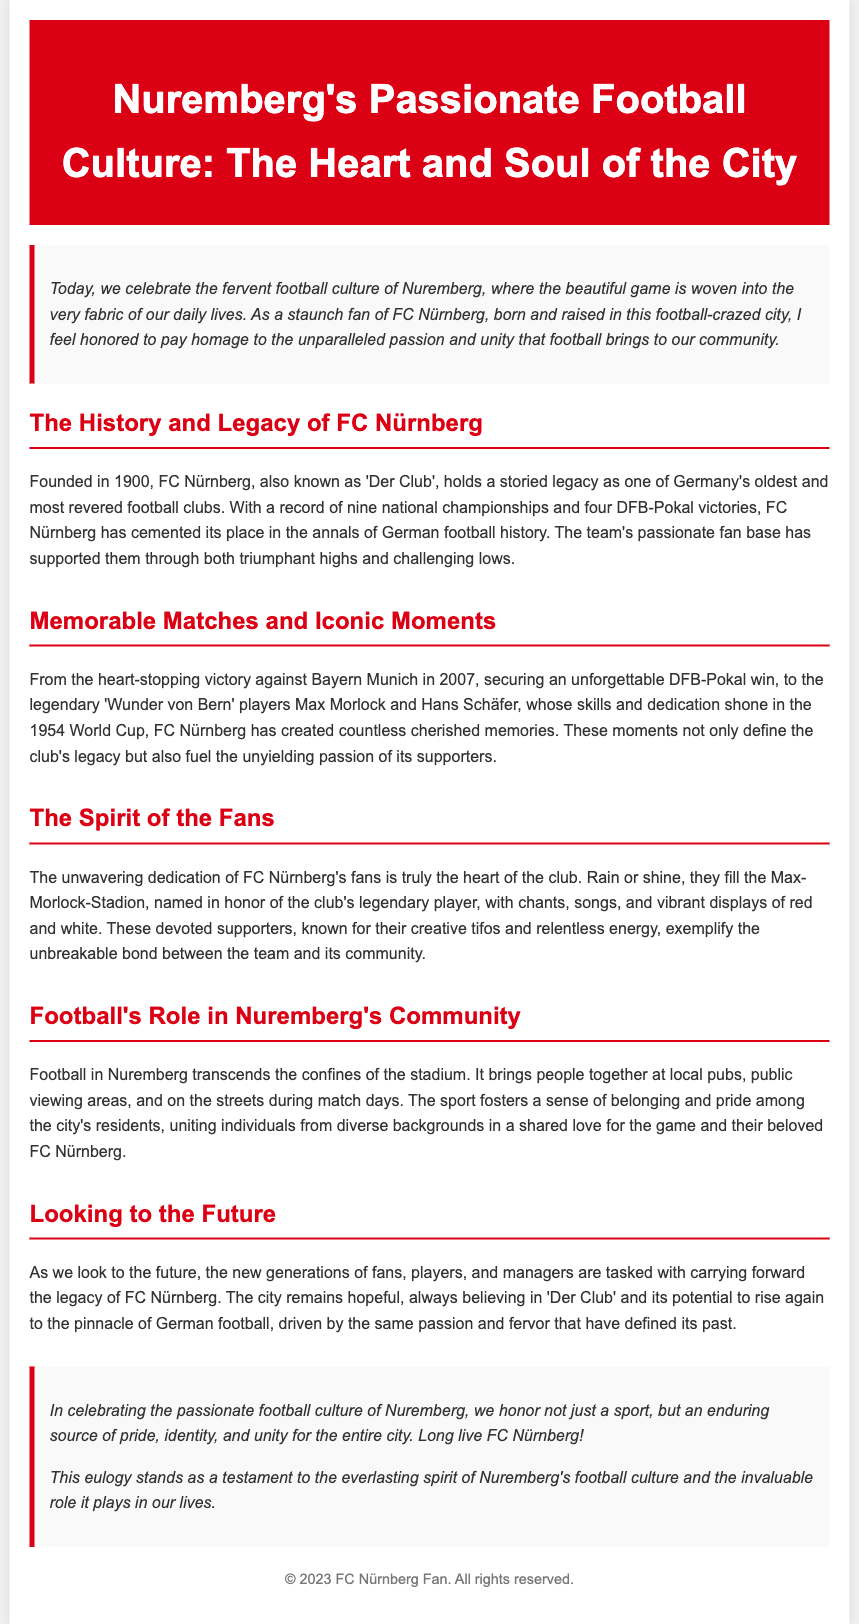What year was FC Nürnberg founded? The document states that FC Nürnberg was founded in 1900.
Answer: 1900 How many national championships has FC Nürnberg won? According to the document, FC Nürnberg has a record of nine national championships.
Answer: Nine What iconic moment is mentioned from the year 2007? The document highlights the heart-stopping victory against Bayern Munich in 2007.
Answer: Victory against Bayern Munich Who are the legendary players mentioned in the 'Wunder von Bern'? The document mentions Max Morlock and Hans Schäfer as the legendary players from the 1954 World Cup.
Answer: Max Morlock and Hans Schäfer What is the name of the stadium associated with FC Nürnberg? The stadium is referred to as the Max-Morlock-Stadion in the document.
Answer: Max-Morlock-Stadion What do the fans of FC Nürnberg exemplify according to the document? The document states that the fans exemplify the unbreakable bond between the team and its community.
Answer: Unbreakable bond Why is football significant in Nuremberg’s community? The document describes football as fostering a sense of belonging and pride among residents.
Answer: Sense of belonging and pride What is the hope for FC Nürnberg's future mentioned in the eulogy? The eulogy expresses hope that FC Nürnberg will rise again to the pinnacle of German football.
Answer: Rise again to the pinnacle What does the eulogy celebrate besides football? It celebrates an enduring source of pride, identity, and unity for the city.
Answer: Pride, identity, and unity 